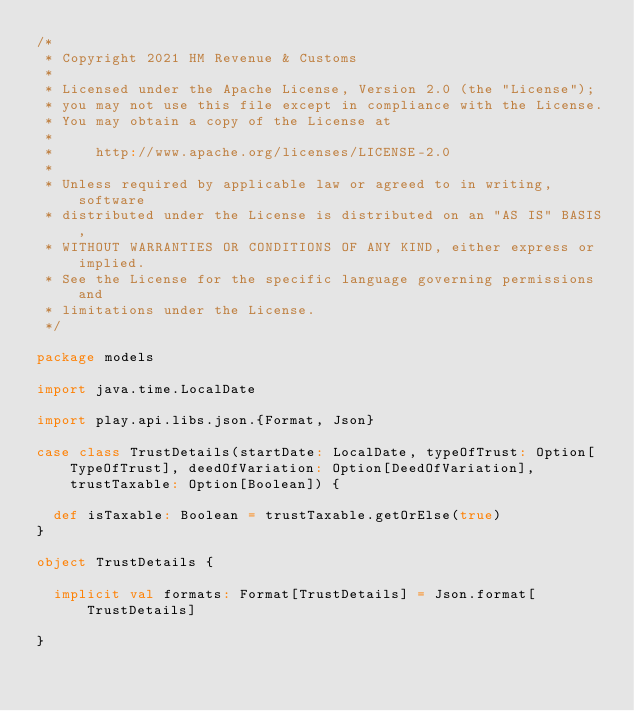<code> <loc_0><loc_0><loc_500><loc_500><_Scala_>/*
 * Copyright 2021 HM Revenue & Customs
 *
 * Licensed under the Apache License, Version 2.0 (the "License");
 * you may not use this file except in compliance with the License.
 * You may obtain a copy of the License at
 *
 *     http://www.apache.org/licenses/LICENSE-2.0
 *
 * Unless required by applicable law or agreed to in writing, software
 * distributed under the License is distributed on an "AS IS" BASIS,
 * WITHOUT WARRANTIES OR CONDITIONS OF ANY KIND, either express or implied.
 * See the License for the specific language governing permissions and
 * limitations under the License.
 */

package models

import java.time.LocalDate

import play.api.libs.json.{Format, Json}

case class TrustDetails(startDate: LocalDate, typeOfTrust: Option[TypeOfTrust], deedOfVariation: Option[DeedOfVariation], trustTaxable: Option[Boolean]) {

  def isTaxable: Boolean = trustTaxable.getOrElse(true)
}

object TrustDetails {

  implicit val formats: Format[TrustDetails] = Json.format[TrustDetails]

}
</code> 